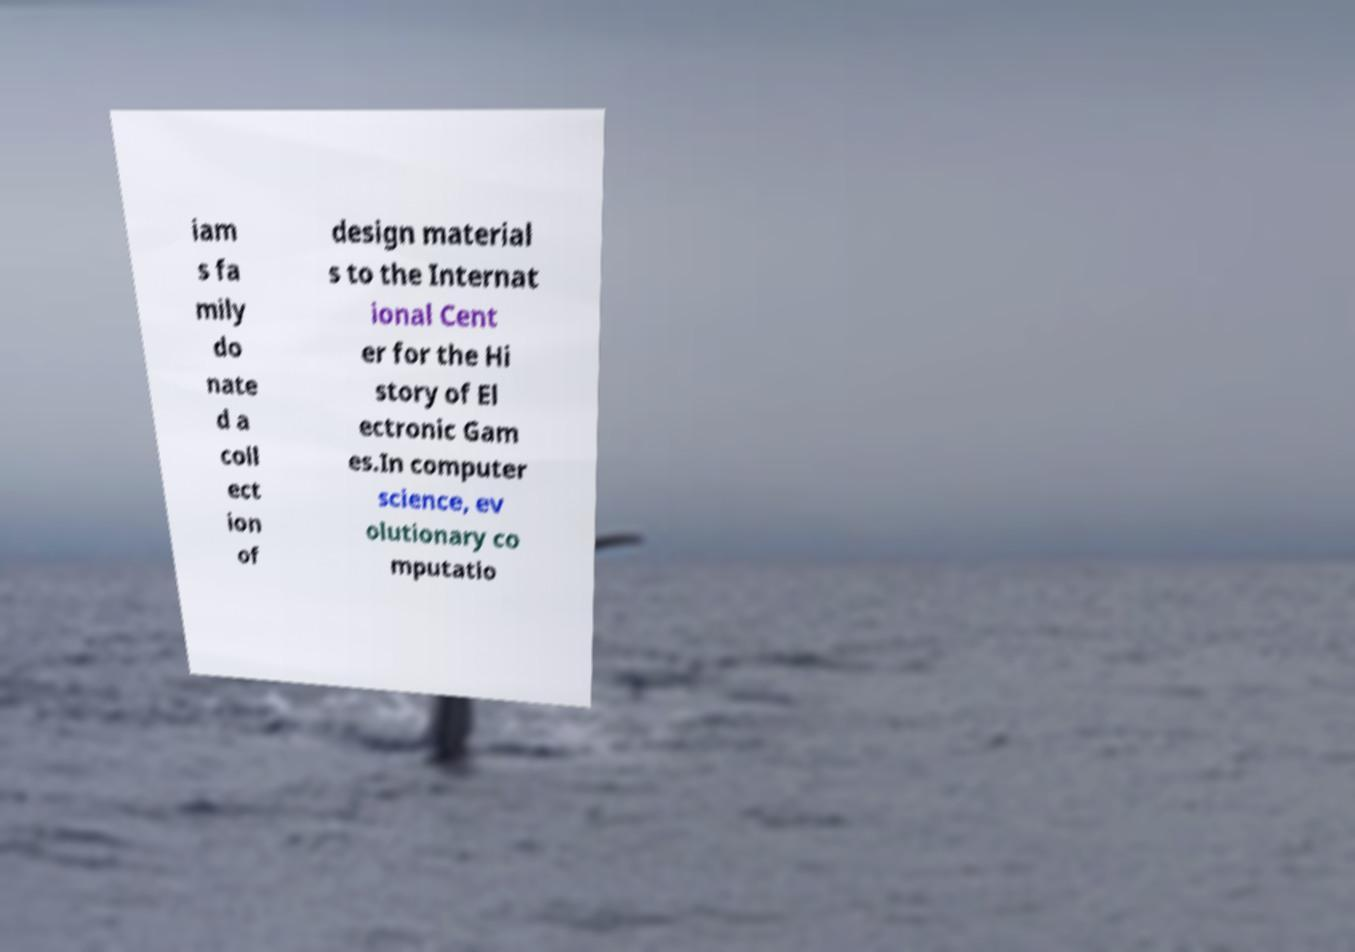Could you assist in decoding the text presented in this image and type it out clearly? iam s fa mily do nate d a coll ect ion of design material s to the Internat ional Cent er for the Hi story of El ectronic Gam es.In computer science, ev olutionary co mputatio 